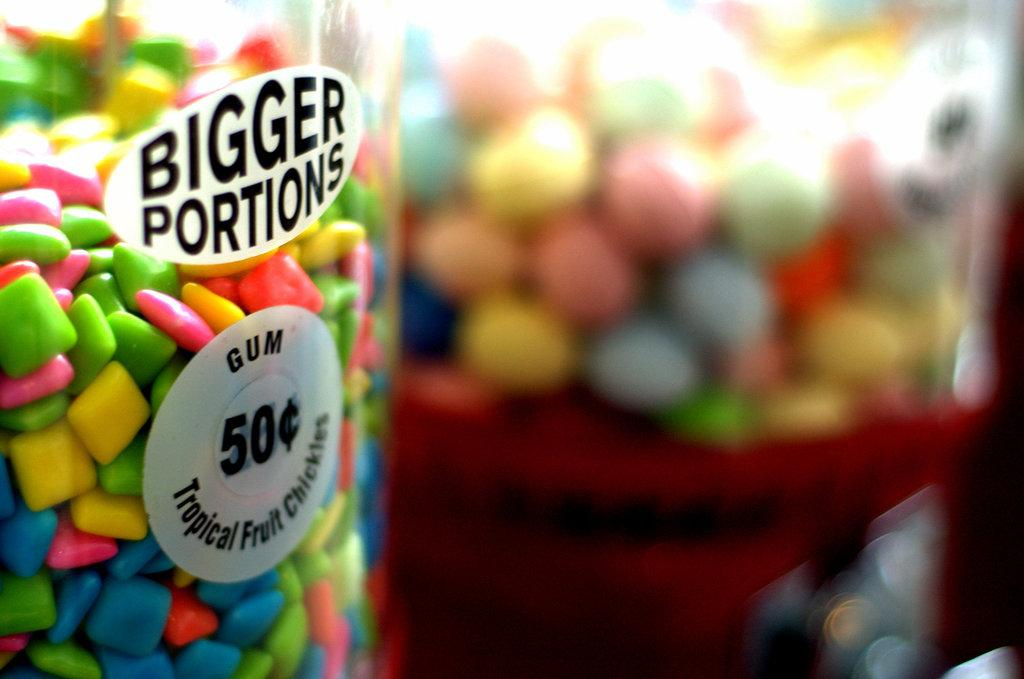What type of confectionery is visible in the image? There is a chewing gum and jars with candies in the image. How many jars with candies are present in the image? There are two jars with candies in the image. Where are the chewing gum and jars located? The chewing gum and jars are on a table. What language is the company logo on the chewing gum package written in? There is no company logo or package visible in the image, as it only shows the chewing gum itself and the jars with candies. 